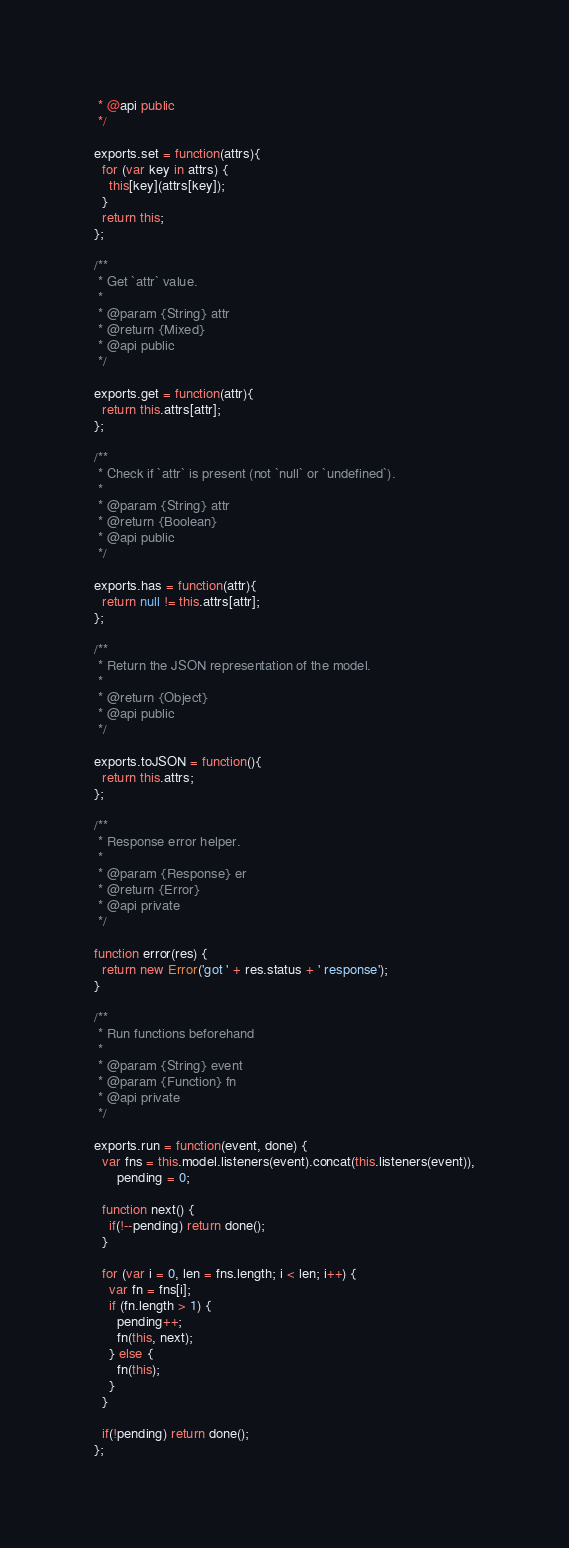<code> <loc_0><loc_0><loc_500><loc_500><_JavaScript_> * @api public
 */

exports.set = function(attrs){
  for (var key in attrs) {
    this[key](attrs[key]);
  }
  return this;
};

/**
 * Get `attr` value.
 *
 * @param {String} attr
 * @return {Mixed}
 * @api public
 */

exports.get = function(attr){
  return this.attrs[attr];
};

/**
 * Check if `attr` is present (not `null` or `undefined`).
 *
 * @param {String} attr
 * @return {Boolean}
 * @api public
 */

exports.has = function(attr){
  return null != this.attrs[attr];
};

/**
 * Return the JSON representation of the model.
 *
 * @return {Object}
 * @api public
 */

exports.toJSON = function(){
  return this.attrs;
};

/**
 * Response error helper.
 *
 * @param {Response} er
 * @return {Error}
 * @api private
 */

function error(res) {
  return new Error('got ' + res.status + ' response');
}

/**
 * Run functions beforehand
 *
 * @param {String} event
 * @param {Function} fn
 * @api private
 */

exports.run = function(event, done) {
  var fns = this.model.listeners(event).concat(this.listeners(event)),
      pending = 0;

  function next() {
    if(!--pending) return done();
  }

  for (var i = 0, len = fns.length; i < len; i++) {
    var fn = fns[i];
    if (fn.length > 1) {
      pending++;
      fn(this, next);
    } else {
      fn(this);
    }
  }

  if(!pending) return done();
};

</code> 